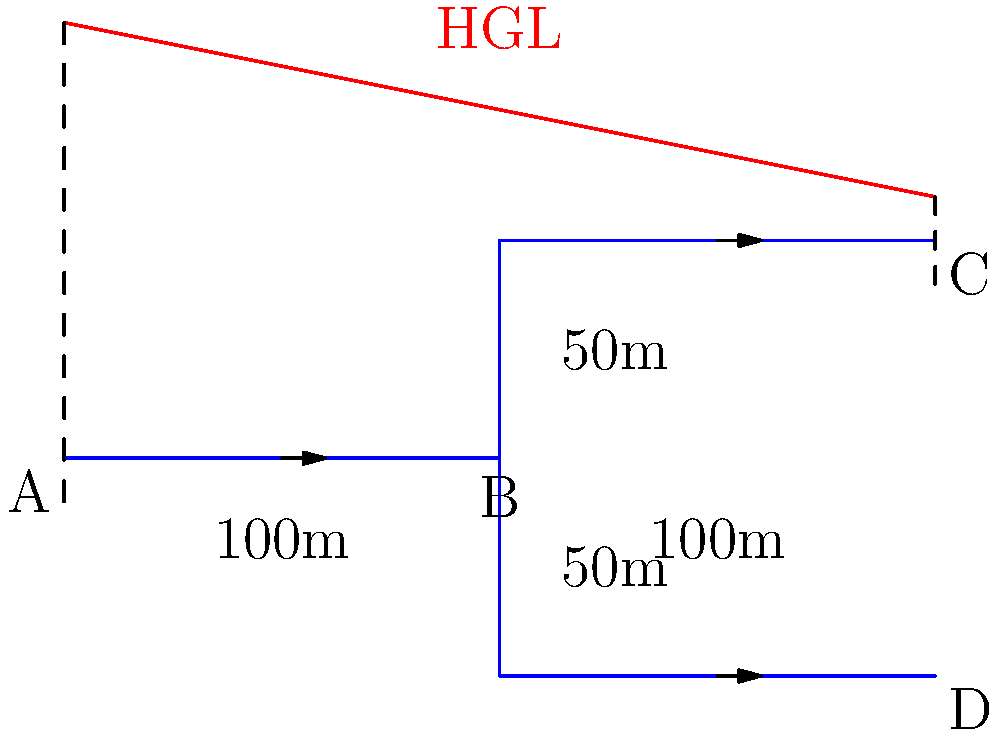In the given hydraulic grade line (HGL) diagram for a pipe network, if the flow rate from point A to B is 0.1 m³/s and the pipe diameter is 0.3 m, what is the approximate flow rate in the pipe section from B to C in m³/s? Assume the pipes have the same diameter and roughness. To solve this problem, we'll use the concept of continuity in fluid mechanics and analyze the hydraulic grade line. Here's a step-by-step approach:

1. Observe that the flow from A splits at point B into two branches: B to C and B to D.

2. The steepness of the hydraulic grade line indicates the rate of energy loss due to friction. A steeper line means higher energy loss and thus higher flow rate.

3. Notice that the HGL slope from B to C is slightly steeper than from B to D. This suggests that the flow rate in B to C is slightly higher than in B to D.

4. By the continuity equation, we know that the sum of flow rates in B to C and B to D must equal the flow rate from A to B:

   $$Q_{AB} = Q_{BC} + Q_{BD}$$

5. Given that $Q_{AB} = 0.1 \text{ m³/s}$, and considering the slightly steeper HGL for B to C, we can estimate that slightly more than half of the flow goes to C.

6. A reasonable estimate would be about 55-60% of the total flow going to C.

7. Calculate the flow rate to C:
   $$Q_{BC} \approx 0.55 \times 0.1 \text{ m³/s} = 0.055 \text{ m³/s}$$

Therefore, the approximate flow rate from B to C is 0.055 m³/s.
Answer: 0.055 m³/s 